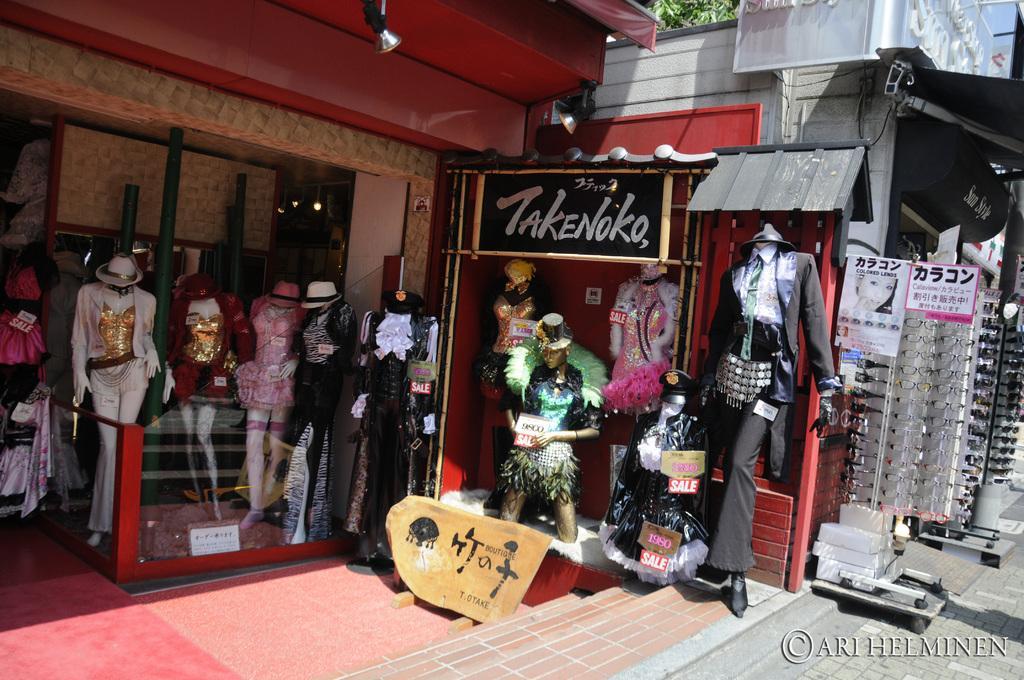Describe this image in one or two sentences. In this image we can see some mannequins dressed with clothes in front of the building, there we can see name board, glass wall, stand, two lights hanging from the roof, some clothes on the shelves, there we can see another shop where some goggles are in the stand and trees. 